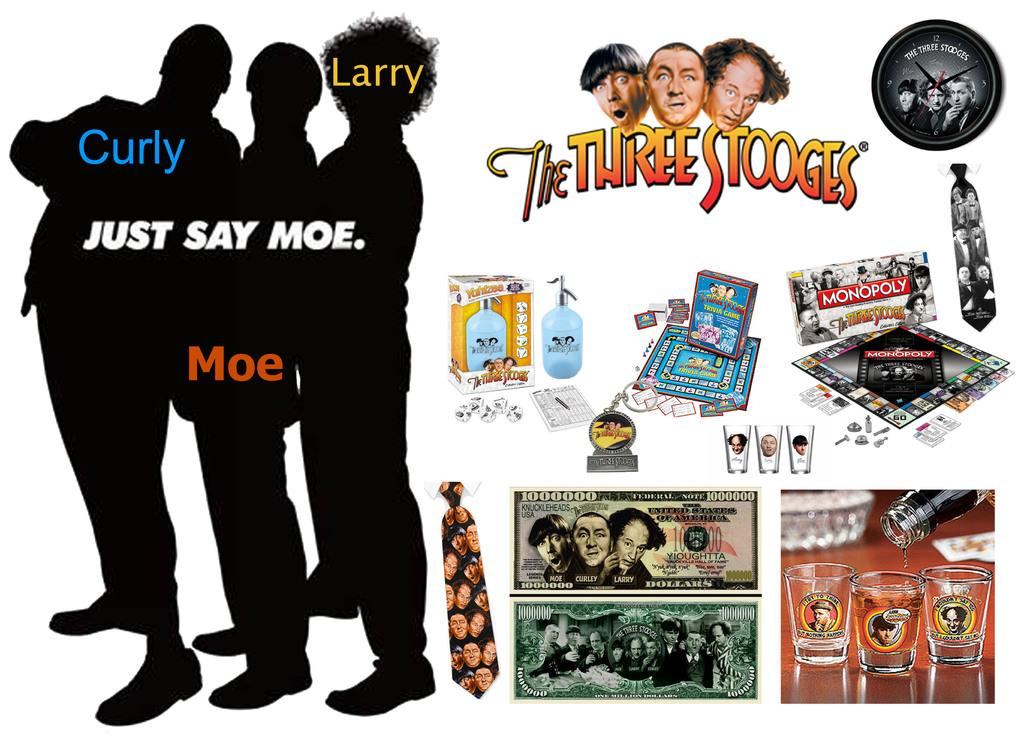<image>
Offer a succinct explanation of the picture presented. A poster dedicated to the Three Stooges has the silhouette of Curly, Larry, and Moe on it as well as images of some of their collectibles. 